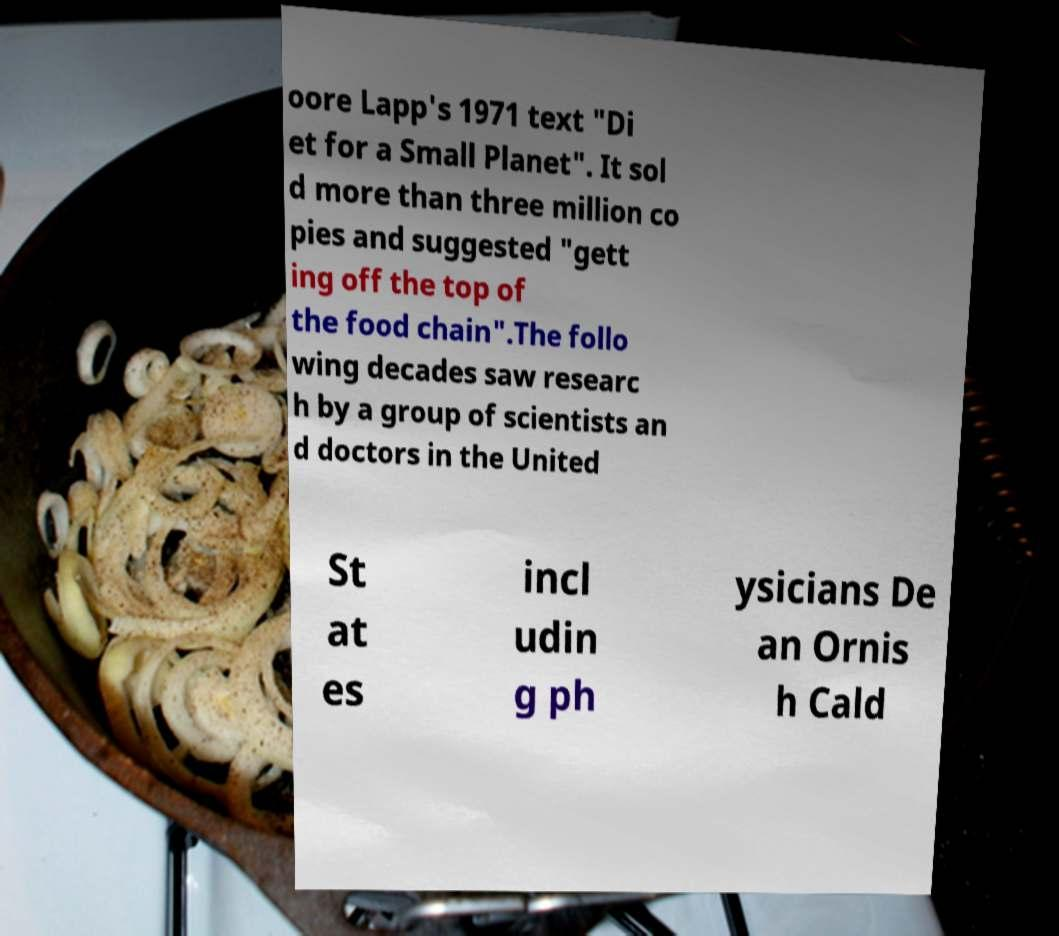Can you read and provide the text displayed in the image?This photo seems to have some interesting text. Can you extract and type it out for me? oore Lapp's 1971 text "Di et for a Small Planet". It sol d more than three million co pies and suggested "gett ing off the top of the food chain".The follo wing decades saw researc h by a group of scientists an d doctors in the United St at es incl udin g ph ysicians De an Ornis h Cald 